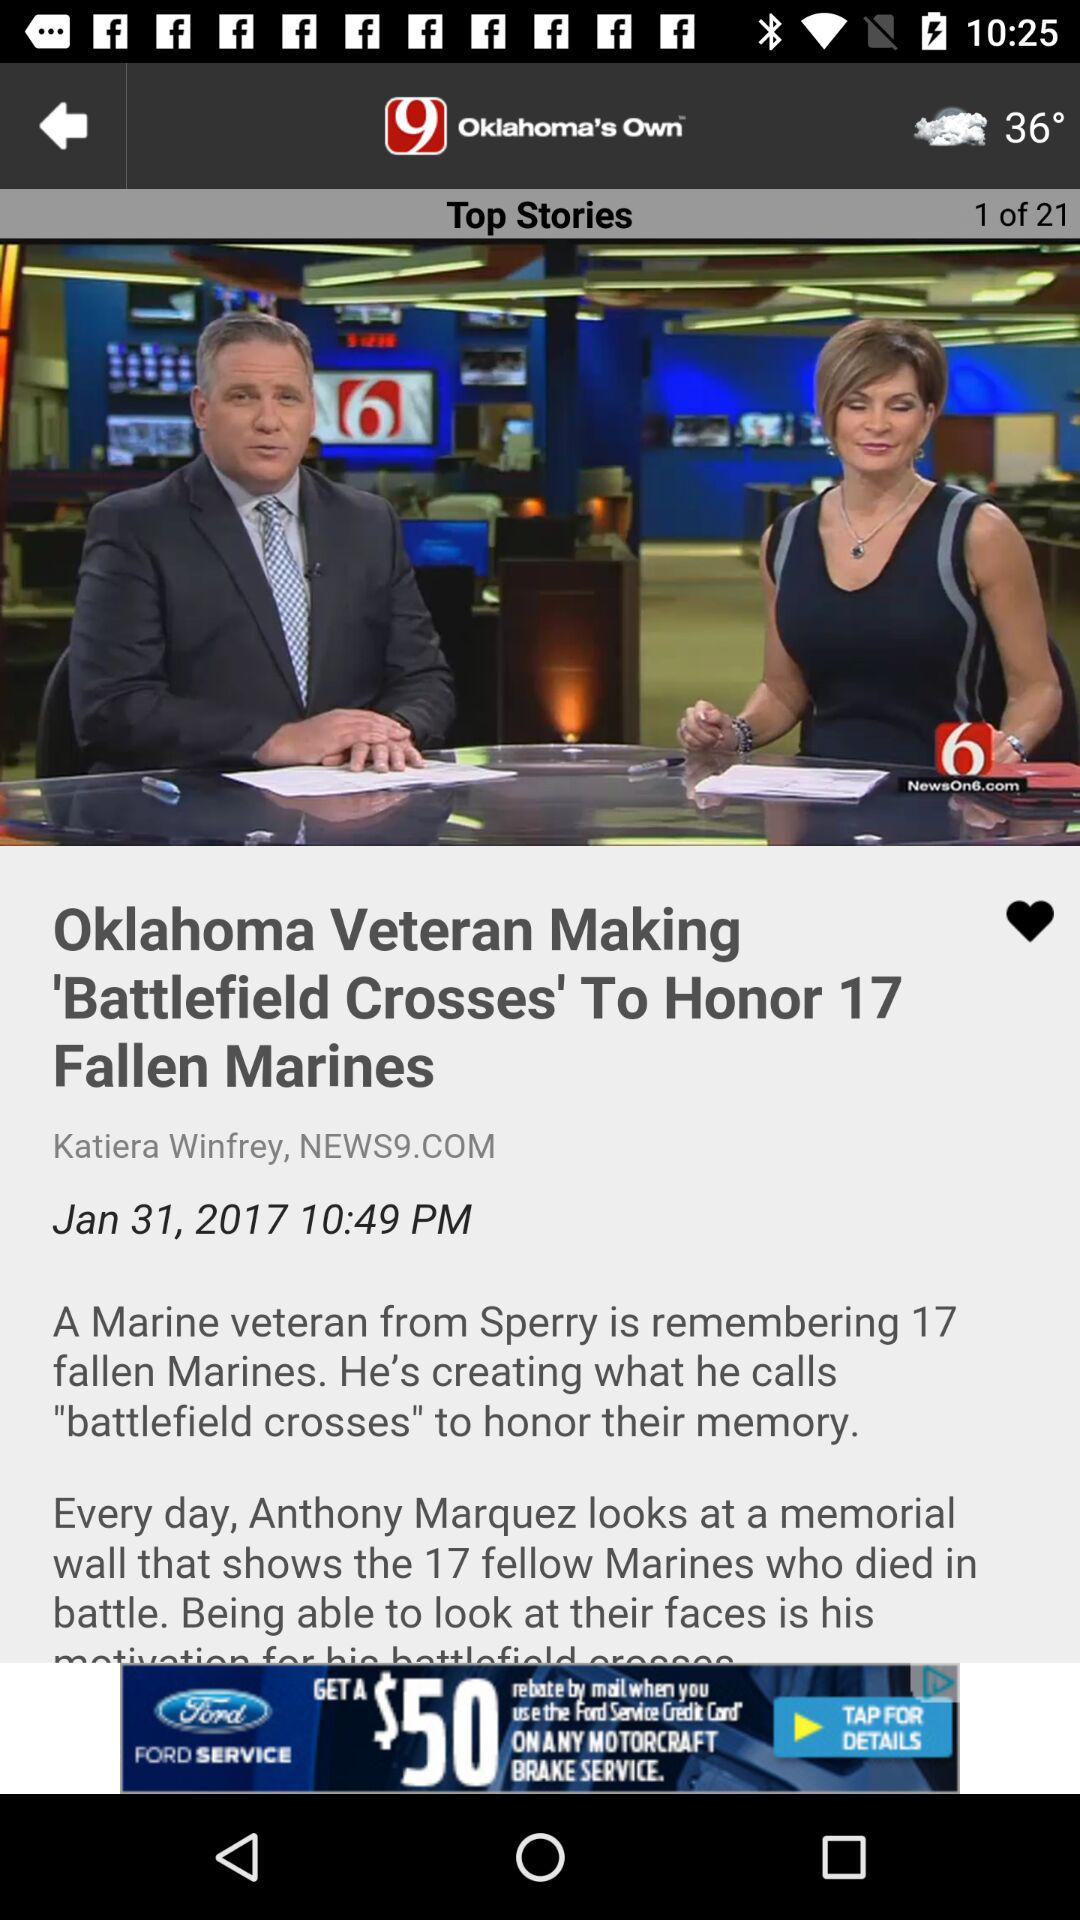What is the date and time? The date is January 31, 2017 and the time is 10:49 PM. 